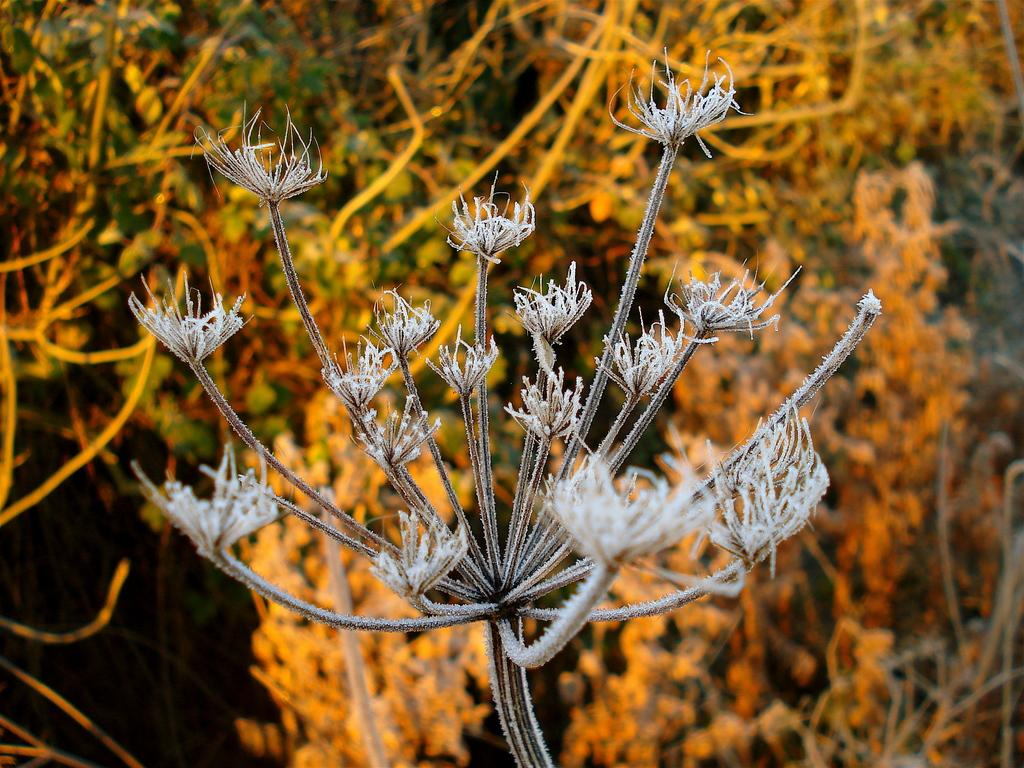What is the main subject of the image? The main subject of the image is a stem with branches. Can you describe the appearance of the stem and branches? The stem has branches, but no further details about their appearance are provided. What can be seen in the background of the image? There are dried plants in the background of the image. How many sisters are present in the image? There are no sisters mentioned or depicted in the image. What type of calendar is hanging on the wall in the image? There is no mention of a wall or a calendar in the image. 